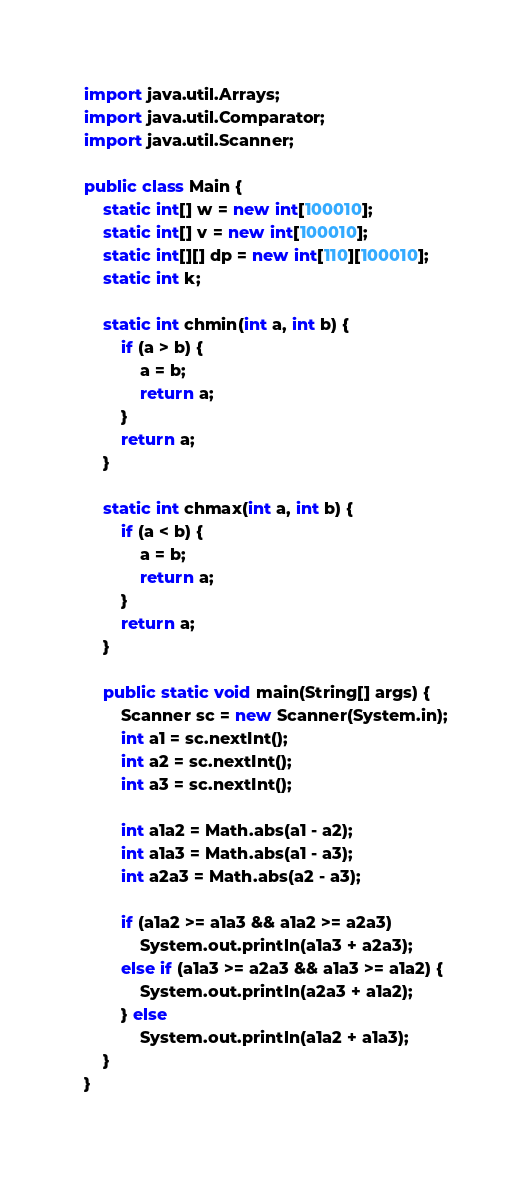Convert code to text. <code><loc_0><loc_0><loc_500><loc_500><_Java_>
import java.util.Arrays;
import java.util.Comparator;
import java.util.Scanner;

public class Main {
    static int[] w = new int[100010];
    static int[] v = new int[100010];
    static int[][] dp = new int[110][100010];
    static int k;

    static int chmin(int a, int b) {
        if (a > b) {
            a = b;
            return a;
        }
        return a;
    }

    static int chmax(int a, int b) {
        if (a < b) {
            a = b;
            return a;
        }
        return a;
    }

    public static void main(String[] args) {
        Scanner sc = new Scanner(System.in);
        int a1 = sc.nextInt();
        int a2 = sc.nextInt();
        int a3 = sc.nextInt();

        int a1a2 = Math.abs(a1 - a2);
        int a1a3 = Math.abs(a1 - a3);
        int a2a3 = Math.abs(a2 - a3);

        if (a1a2 >= a1a3 && a1a2 >= a2a3)
            System.out.println(a1a3 + a2a3);
        else if (a1a3 >= a2a3 && a1a3 >= a1a2) {
            System.out.println(a2a3 + a1a2);
        } else
            System.out.println(a1a2 + a1a3);
    }
}
</code> 